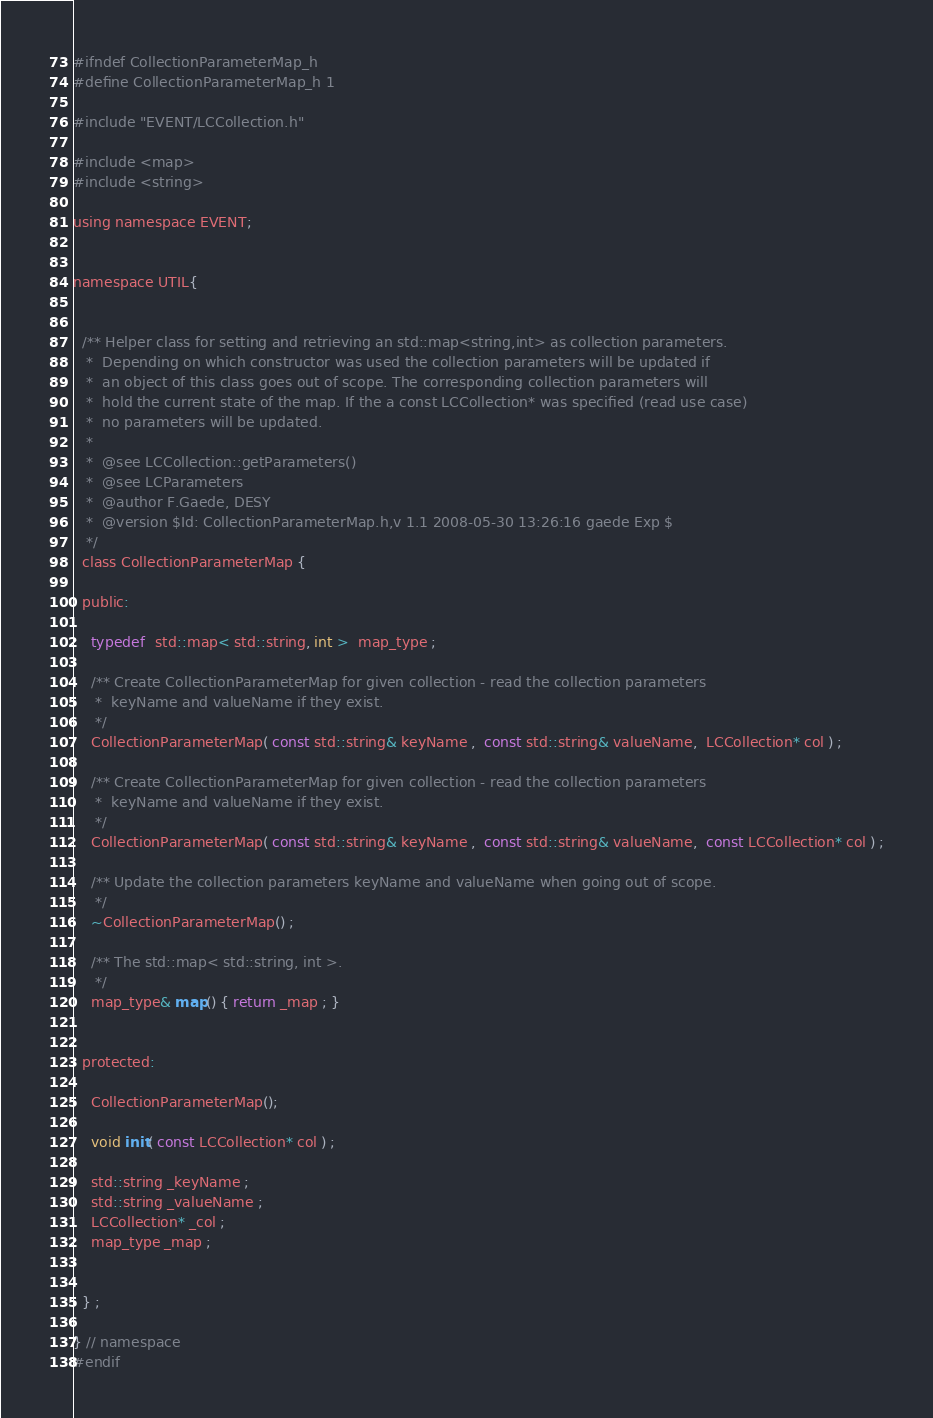<code> <loc_0><loc_0><loc_500><loc_500><_C_>#ifndef CollectionParameterMap_h
#define CollectionParameterMap_h 1

#include "EVENT/LCCollection.h"

#include <map>
#include <string>

using namespace EVENT;


namespace UTIL{
  
  
  /** Helper class for setting and retrieving an std::map<string,int> as collection parameters.
   *  Depending on which constructor was used the collection parameters will be updated if
   *  an object of this class goes out of scope. The corresponding collection parameters will
   *  hold the current state of the map. If the a const LCCollection* was specified (read use case)
   *  no parameters will be updated.
   *
   *  @see LCCollection::getParameters()
   *  @see LCParameters
   *  @author F.Gaede, DESY
   *  @version $Id: CollectionParameterMap.h,v 1.1 2008-05-30 13:26:16 gaede Exp $
   */
  class CollectionParameterMap {

  public:  
    
    typedef  std::map< std::string, int >  map_type ;

    /** Create CollectionParameterMap for given collection - read the collection parameters
     *  keyName and valueName if they exist.
     */
    CollectionParameterMap( const std::string& keyName ,  const std::string& valueName,  LCCollection* col ) ;
    
    /** Create CollectionParameterMap for given collection - read the collection parameters
     *  keyName and valueName if they exist.
     */
    CollectionParameterMap( const std::string& keyName ,  const std::string& valueName,  const LCCollection* col ) ;

    /** Update the collection parameters keyName and valueName when going out of scope.
     */
    ~CollectionParameterMap() ;

    /** The std::map< std::string, int >.
     */
    map_type& map() { return _map ; }


  protected:

    CollectionParameterMap();
    
    void init( const LCCollection* col ) ; 
 
    std::string _keyName ;
    std::string _valueName ;
    LCCollection* _col ;
    map_type _map ;


  } ; 
  
} // namespace
#endif


</code> 